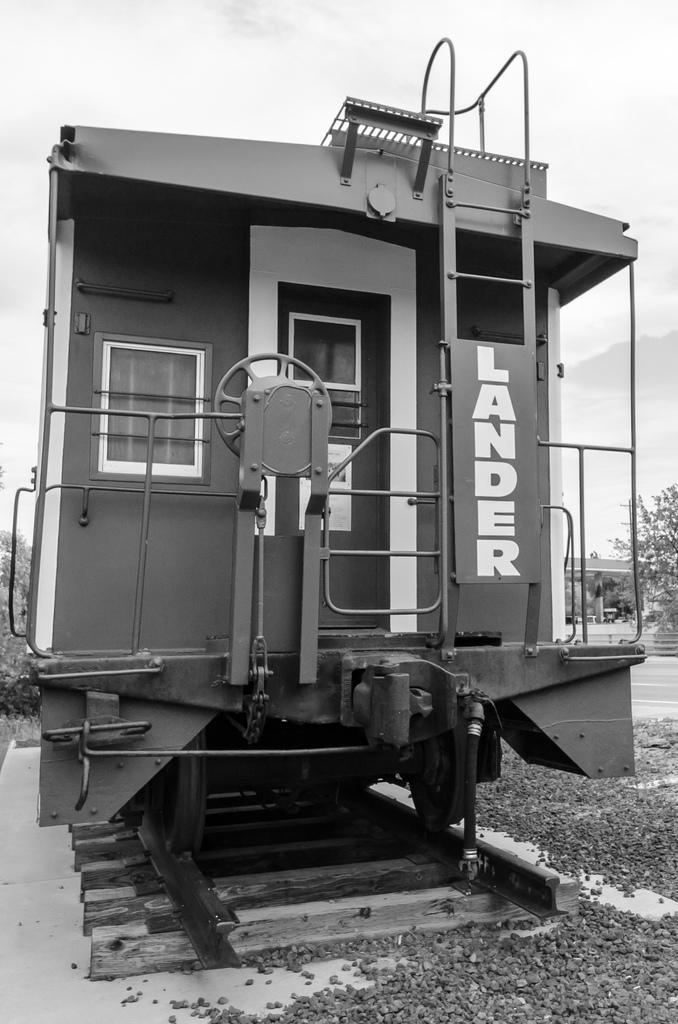What is the main subject of the image? The main subject of the image is a train. Where is the train located? The train is on a railway track. What can be seen on the train? There is text on the train. What type of vegetation is visible in the image? There are trees visible in the image. What is the weather like in the image? The sky is cloudy in the image. What type of ground surface is present in the image? There are small stones on the ground. Can you tell me how many boys are standing next to the train in the image? There are no boys present in the image; it features a train on a railway track with trees and a cloudy sky. What type of fairies can be seen flying around the train in the image? There are no fairies present in the image; it features a train on a railway track with trees and a cloudy sky. 